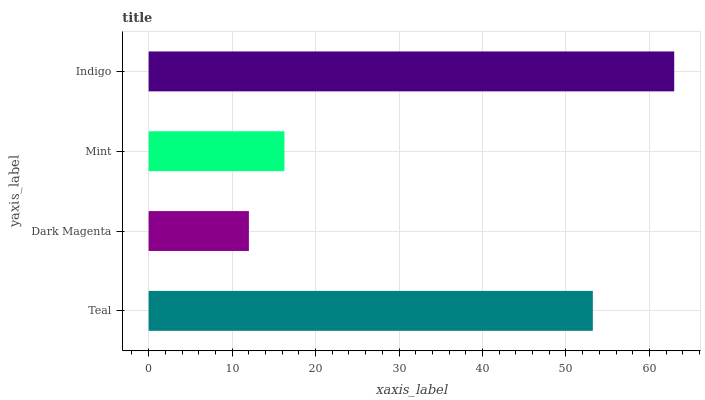Is Dark Magenta the minimum?
Answer yes or no. Yes. Is Indigo the maximum?
Answer yes or no. Yes. Is Mint the minimum?
Answer yes or no. No. Is Mint the maximum?
Answer yes or no. No. Is Mint greater than Dark Magenta?
Answer yes or no. Yes. Is Dark Magenta less than Mint?
Answer yes or no. Yes. Is Dark Magenta greater than Mint?
Answer yes or no. No. Is Mint less than Dark Magenta?
Answer yes or no. No. Is Teal the high median?
Answer yes or no. Yes. Is Mint the low median?
Answer yes or no. Yes. Is Indigo the high median?
Answer yes or no. No. Is Indigo the low median?
Answer yes or no. No. 